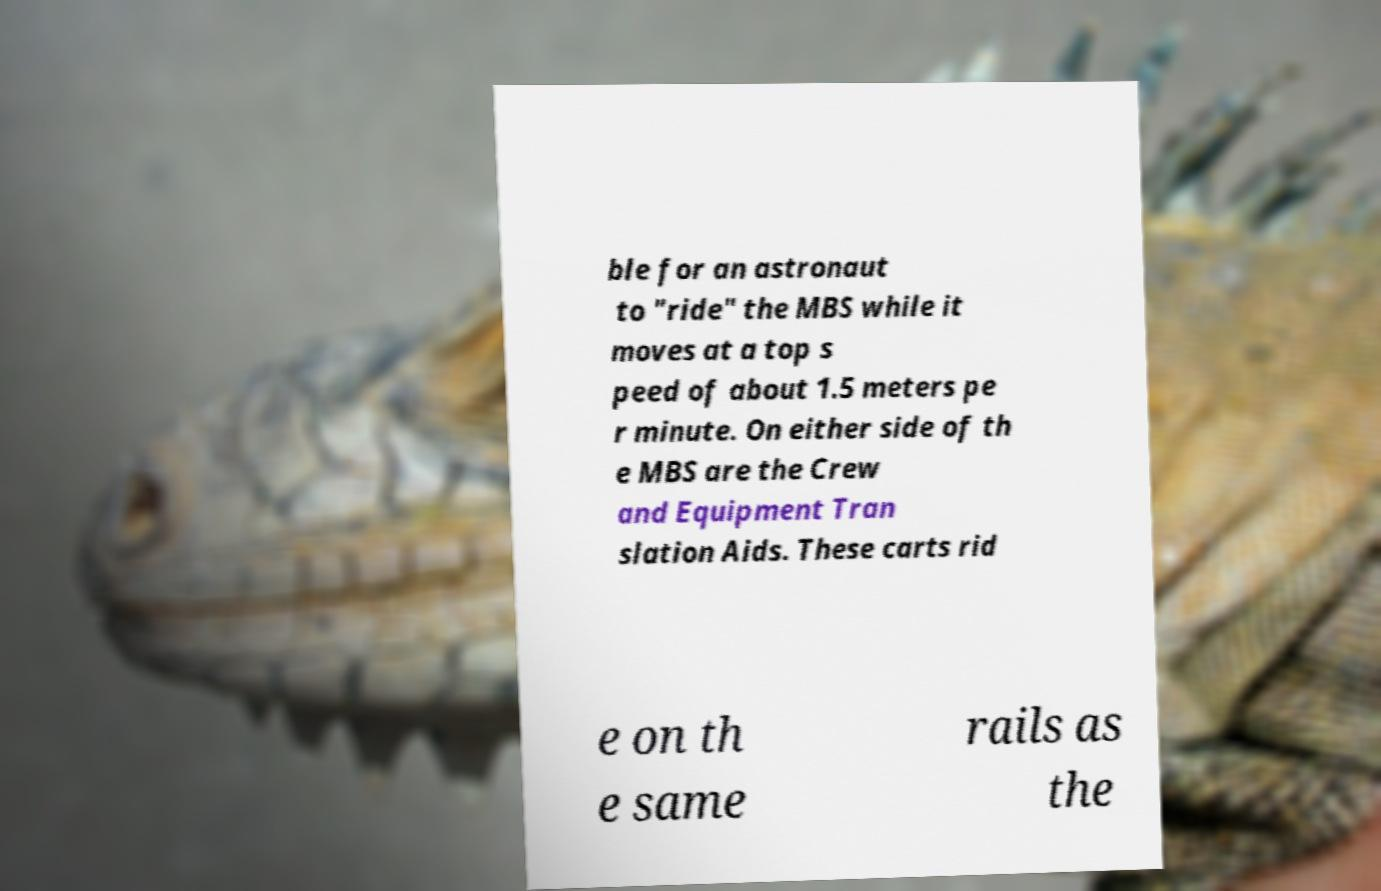Please read and relay the text visible in this image. What does it say? ble for an astronaut to "ride" the MBS while it moves at a top s peed of about 1.5 meters pe r minute. On either side of th e MBS are the Crew and Equipment Tran slation Aids. These carts rid e on th e same rails as the 